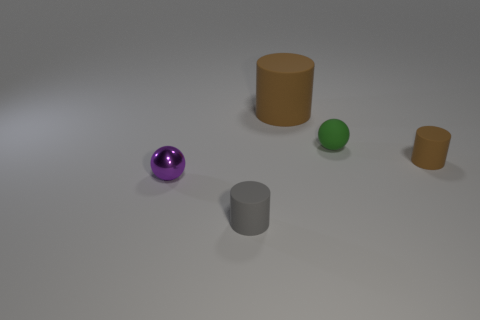Add 1 large brown matte objects. How many objects exist? 6 Subtract all balls. How many objects are left? 3 Add 4 big brown cylinders. How many big brown cylinders are left? 5 Add 4 large green rubber cubes. How many large green rubber cubes exist? 4 Subtract 0 gray spheres. How many objects are left? 5 Subtract all purple objects. Subtract all tiny purple things. How many objects are left? 3 